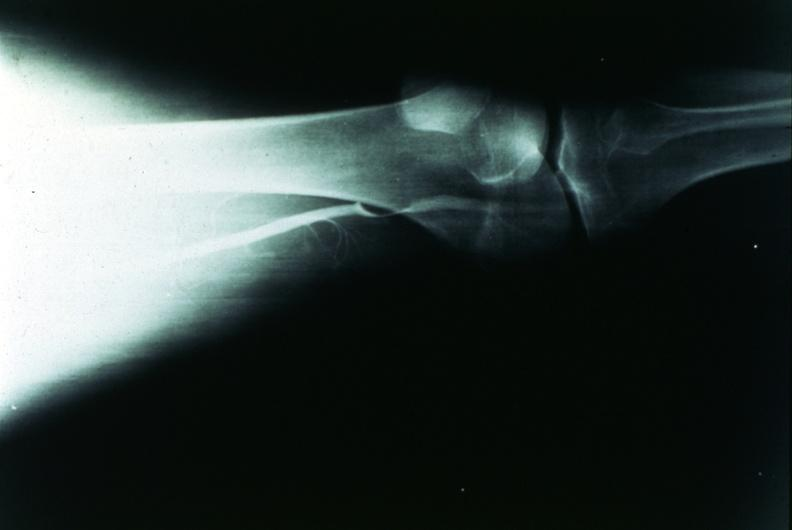s joints present?
Answer the question using a single word or phrase. Yes 